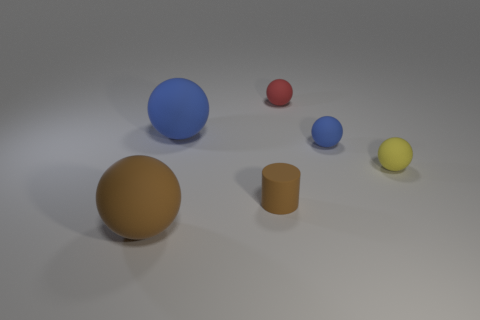There is a thing that is the same color as the tiny cylinder; what size is it?
Your answer should be very brief. Large. There is a big thing that is the same color as the matte cylinder; what shape is it?
Offer a terse response. Sphere. The other large matte thing that is the same shape as the large brown rubber object is what color?
Keep it short and to the point. Blue. Are there any other things that have the same color as the cylinder?
Provide a succinct answer. Yes. How many other things are there of the same material as the small blue ball?
Your answer should be very brief. 5. What size is the yellow matte thing?
Ensure brevity in your answer.  Small. Is there another matte object of the same shape as the tiny blue rubber thing?
Offer a very short reply. Yes. What number of objects are either small things or big matte balls behind the tiny yellow sphere?
Give a very brief answer. 5. What color is the big rubber sphere in front of the big blue matte sphere?
Ensure brevity in your answer.  Brown. Do the rubber sphere in front of the yellow rubber sphere and the blue matte ball on the left side of the brown cylinder have the same size?
Your response must be concise. Yes. 